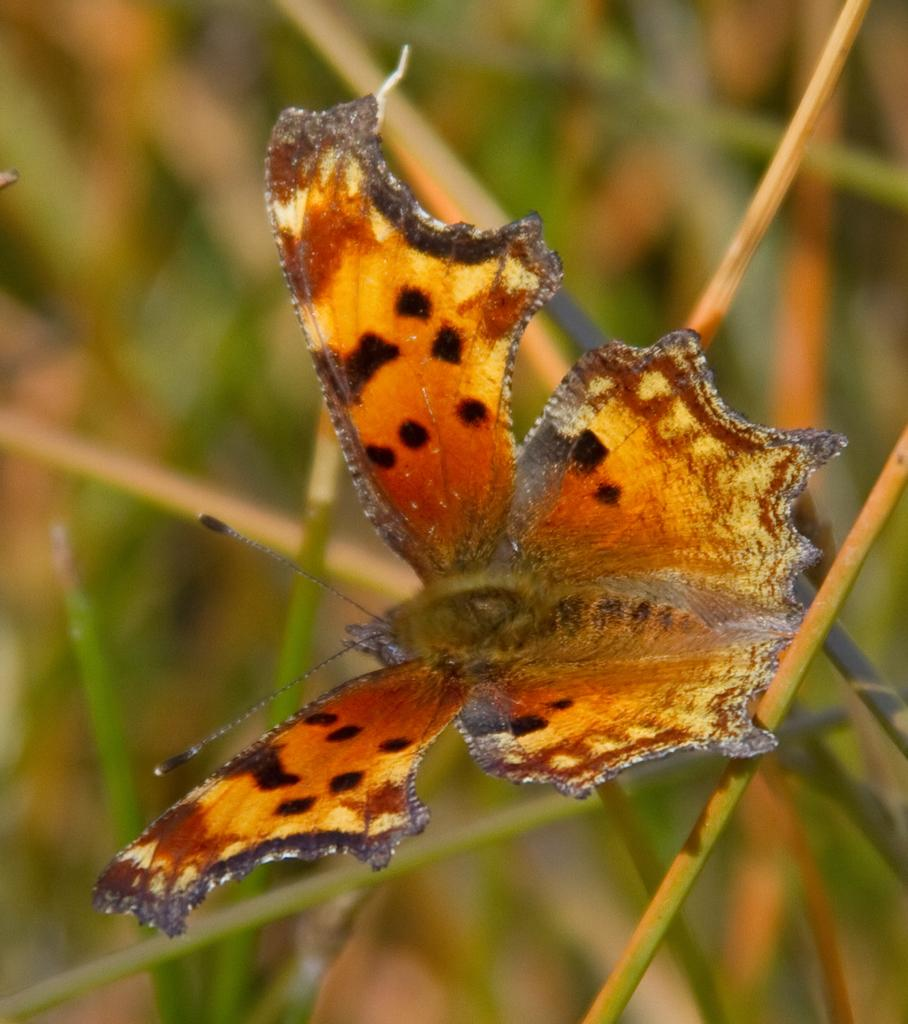What is the main subject of the image? The main subject of the image is a butterfly. Where is the butterfly located in the image? The butterfly is on the grass. What type of card is the butterfly holding in the image? There is no card present in the image, as butterflies do not have the ability to hold objects. 